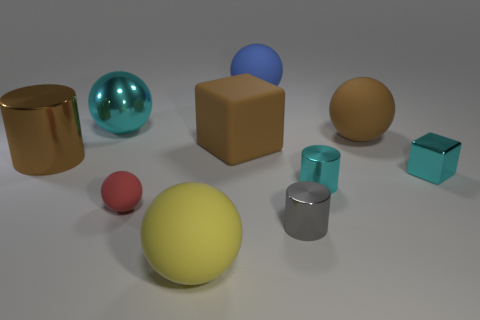What color is the large ball to the left of the rubber thing that is left of the large yellow rubber sphere?
Offer a terse response. Cyan. What number of other objects are there of the same material as the brown cylinder?
Provide a short and direct response. 4. Are there an equal number of tiny red matte spheres and large brown rubber objects?
Offer a very short reply. No. What number of shiny objects are big gray objects or tiny red spheres?
Your response must be concise. 0. What is the color of the other large shiny thing that is the same shape as the big blue object?
Your answer should be compact. Cyan. What number of things are brown rubber spheres or small red matte balls?
Provide a short and direct response. 2. There is a large cyan thing that is made of the same material as the gray thing; what shape is it?
Provide a short and direct response. Sphere. How many tiny objects are gray rubber things or brown matte balls?
Your answer should be very brief. 0. What number of other things are there of the same color as the big matte block?
Give a very brief answer. 2. How many tiny gray metallic things are on the left side of the cyan metallic thing that is left of the large matte thing that is behind the big cyan metallic sphere?
Give a very brief answer. 0. 